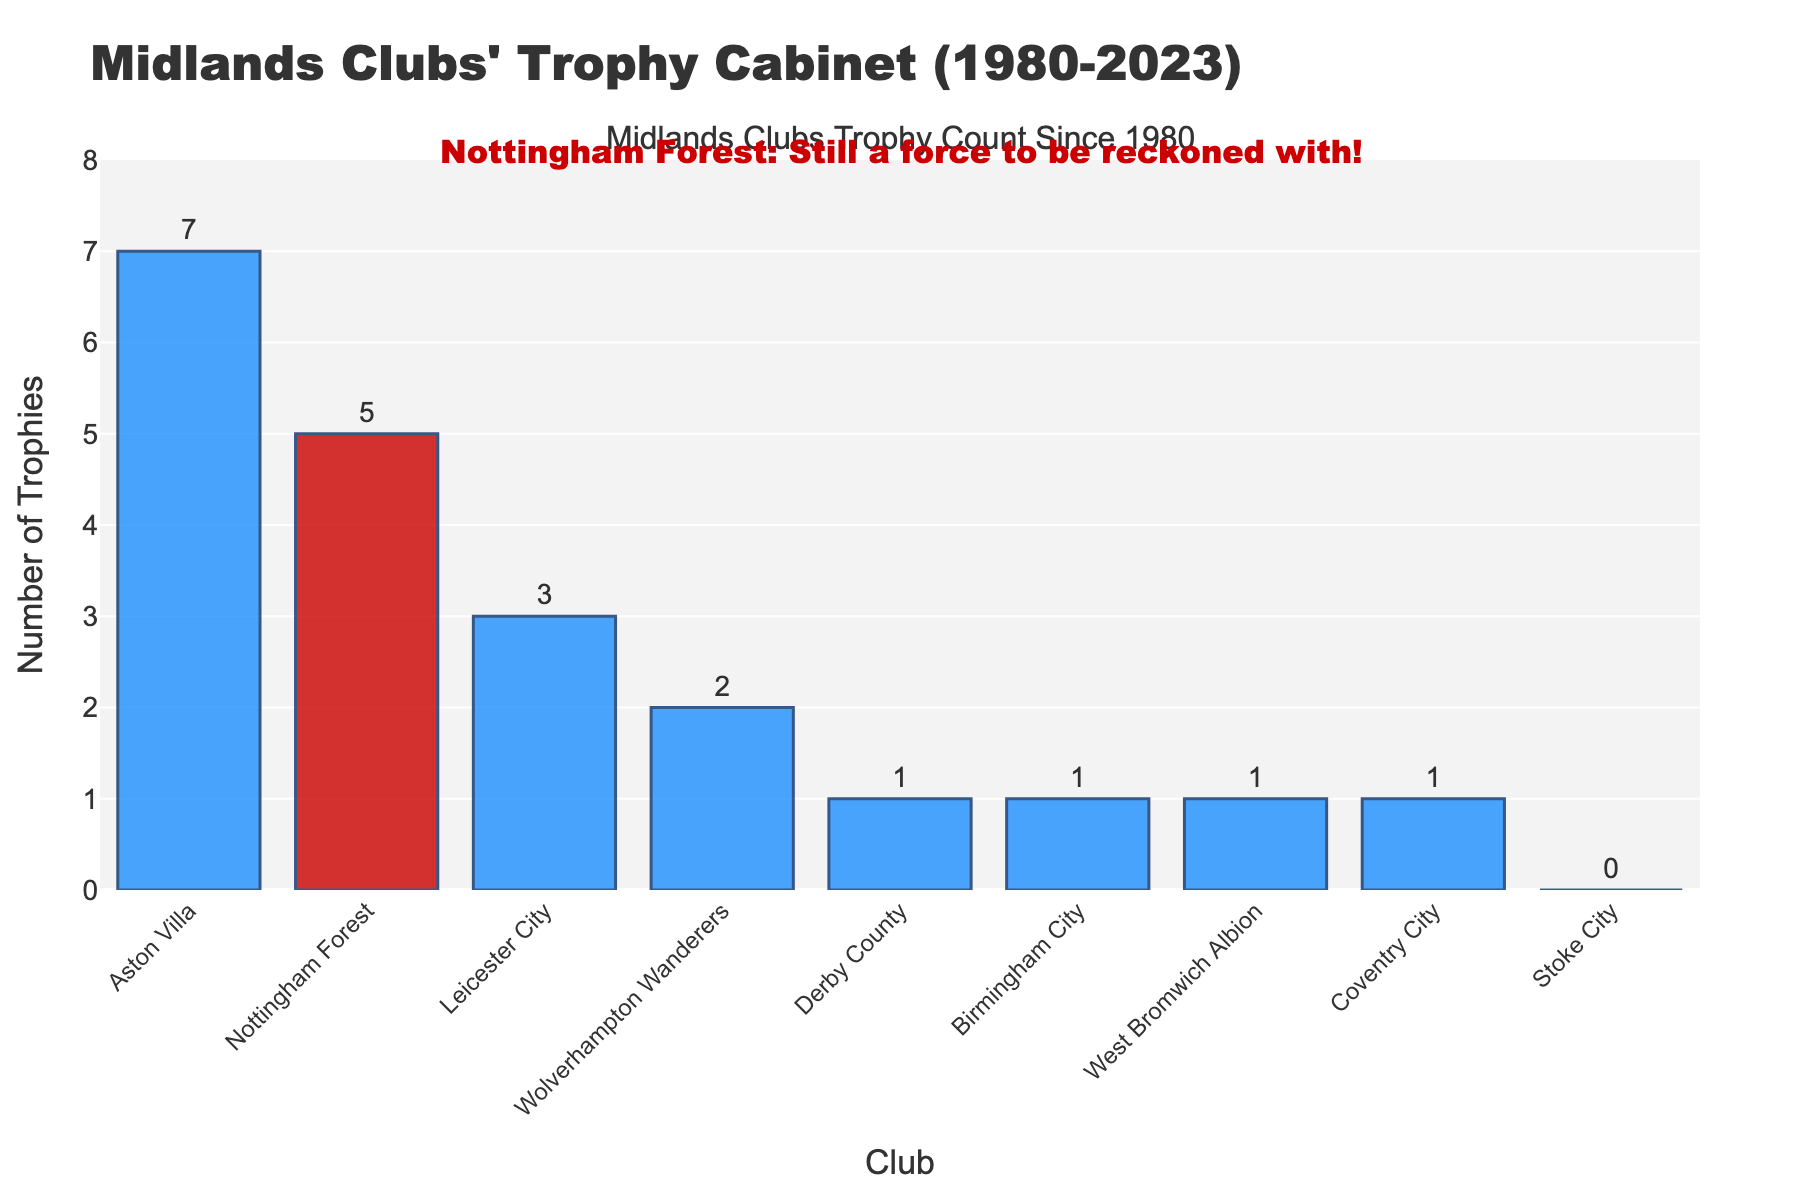How many more trophies has Aston Villa won compared to Derby County? To find out how many more trophies Aston Villa has won compared to Derby County, subtract Derby County's trophies from Aston Villa's trophies: 7 (Aston Villa) - 1 (Derby County) = 6.
Answer: 6 Which club has won the fewest trophies since 1980? To determine which club has won the fewest trophies, look for the club with the smallest number in the bar chart. Stoke City has won 0 trophies.
Answer: Stoke City What is the total number of trophies won by all clubs combined? Add up the number of trophies for all the clubs: 5 (Nottingham Forest) + 7 (Aston Villa) + 3 (Leicester City) + 1 (Derby County) + 1 (Birmingham City) + 2 (Wolverhampton Wanderers) + 1 (West Bromwich Albion) + 1 (Coventry City) + 0 (Stoke City) = 21
Answer: 21 Are there any clubs with the same number of trophies? To find if any clubs have the same number of trophies, compare each club's trophy count. Derby County, Birmingham City, West Bromwich Albion, and Coventry City each have 1 trophy.
Answer: Yes, Derby County, Birmingham City, West Bromwich Albion, and Coventry City each have 1 What percentage of total trophies won by Midlands clubs were won by Nottingham Forest? First, calculate the total number of trophies: 21. Then divide Nottingham Forest's trophies by the total and multiply by 100. (5 / 21) * 100 ≈ 23.81%
Answer: ≈23.81% Which club has won more trophies: Birmingham City or Wolverhampton Wanderers? To determine which club has more trophies, compare Birmingham City's trophies (1) and Wolverhampton Wanderers' trophies (2).
Answer: Wolverhampton Wanderers How many clubs have won more than 2 trophies? Check the bar chart for the number of clubs with more than 2 trophies. Those are Nottingham Forest (5), Aston Villa (7), and Leicester City (3). Three clubs.
Answer: 3 What is the difference in trophies between the club with the most and the club with the least? Subtract the trophies of the club with the least from the club with the most: 7 (Aston Villa) - 0 (Stoke City) = 7.
Answer: 7 What is the average number of trophies won per club? Calculate the total number of trophies (21) and divide by the number of clubs (9). 21 / 9 ≈ 2.33
Answer: ≈2.33 What do the colors of the bars in the bar chart represent? The colors distinguish Nottingham Forest from other Midlands clubs. Nottingham Forest is shown in red, and the other clubs are in blue.
Answer: Nottingham Forest in red and other clubs in blue 